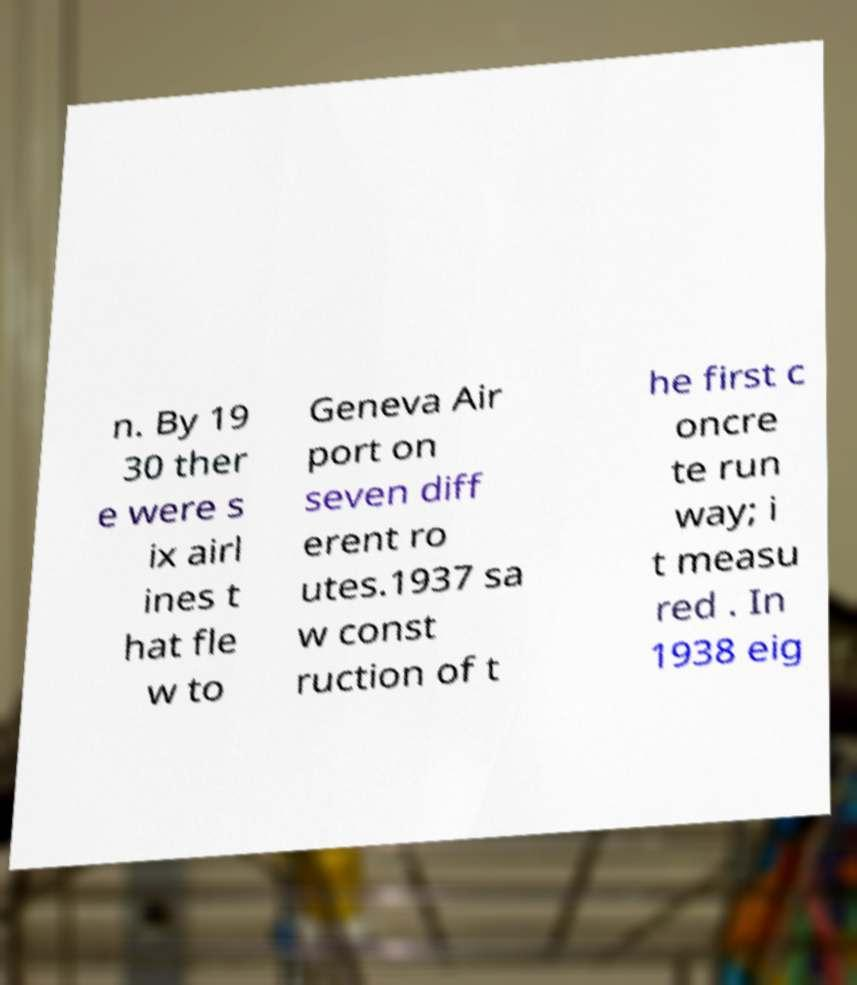I need the written content from this picture converted into text. Can you do that? n. By 19 30 ther e were s ix airl ines t hat fle w to Geneva Air port on seven diff erent ro utes.1937 sa w const ruction of t he first c oncre te run way; i t measu red . In 1938 eig 